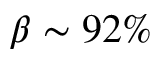<formula> <loc_0><loc_0><loc_500><loc_500>\beta \sim 9 2 \%</formula> 